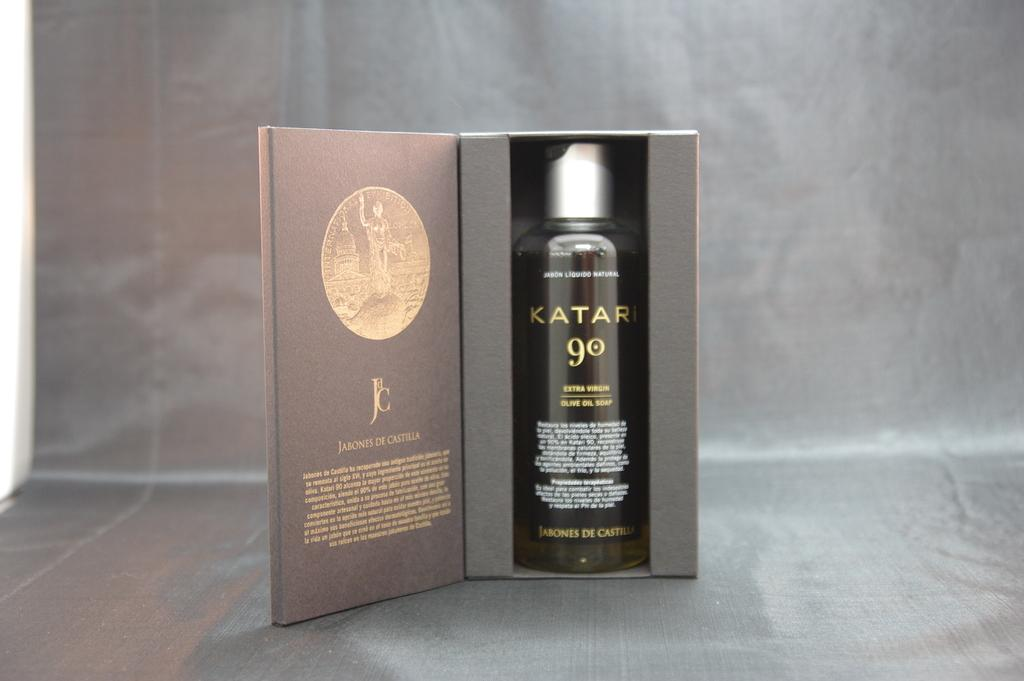<image>
Render a clear and concise summary of the photo. Katari 90 extra virgin olive oil soap is displayed in an attractive box. 